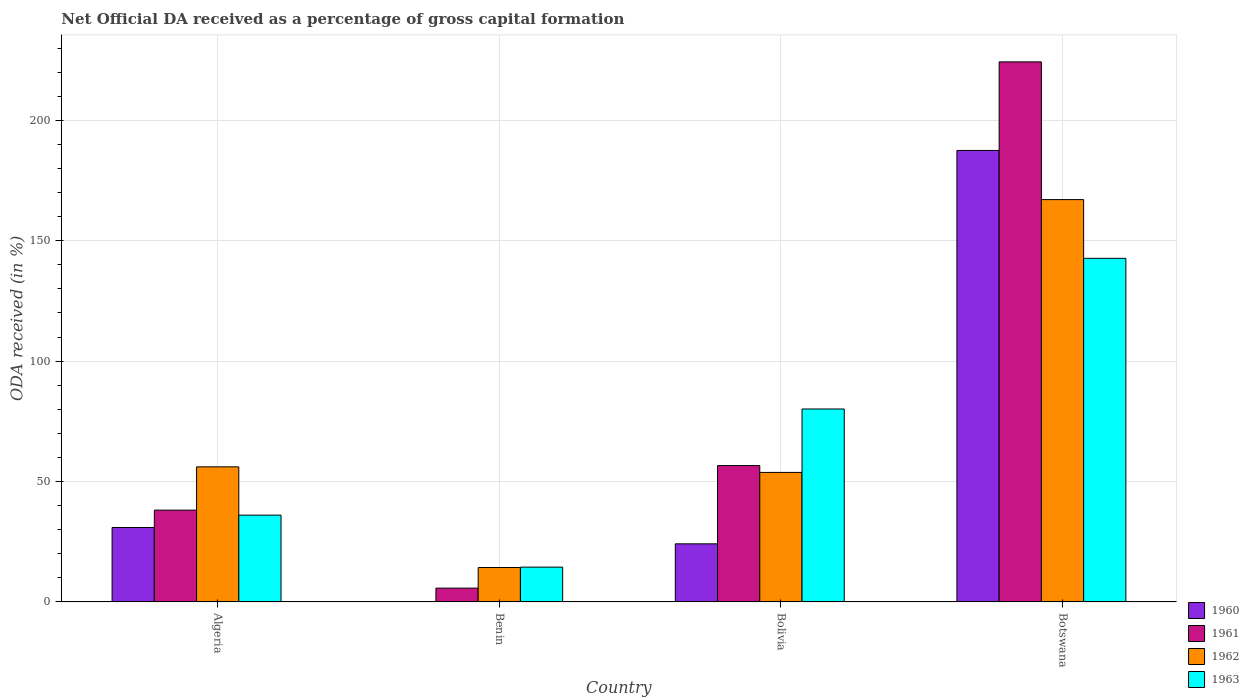How many bars are there on the 1st tick from the right?
Your response must be concise. 4. What is the label of the 3rd group of bars from the left?
Give a very brief answer. Bolivia. In how many cases, is the number of bars for a given country not equal to the number of legend labels?
Offer a terse response. 0. What is the net ODA received in 1960 in Bolivia?
Give a very brief answer. 24.12. Across all countries, what is the maximum net ODA received in 1963?
Make the answer very short. 142.68. Across all countries, what is the minimum net ODA received in 1962?
Your answer should be very brief. 14.28. In which country was the net ODA received in 1963 maximum?
Provide a short and direct response. Botswana. In which country was the net ODA received in 1960 minimum?
Your answer should be compact. Benin. What is the total net ODA received in 1960 in the graph?
Your answer should be compact. 242.58. What is the difference between the net ODA received in 1963 in Algeria and that in Benin?
Offer a terse response. 21.6. What is the difference between the net ODA received in 1962 in Botswana and the net ODA received in 1961 in Algeria?
Your answer should be compact. 128.96. What is the average net ODA received in 1963 per country?
Make the answer very short. 68.32. What is the difference between the net ODA received of/in 1961 and net ODA received of/in 1963 in Benin?
Offer a very short reply. -8.71. What is the ratio of the net ODA received in 1962 in Algeria to that in Botswana?
Offer a very short reply. 0.34. Is the net ODA received in 1960 in Algeria less than that in Botswana?
Offer a terse response. Yes. Is the difference between the net ODA received in 1961 in Algeria and Botswana greater than the difference between the net ODA received in 1963 in Algeria and Botswana?
Your answer should be very brief. No. What is the difference between the highest and the second highest net ODA received in 1961?
Make the answer very short. 167.65. What is the difference between the highest and the lowest net ODA received in 1962?
Your answer should be compact. 152.79. In how many countries, is the net ODA received in 1962 greater than the average net ODA received in 1962 taken over all countries?
Ensure brevity in your answer.  1. Is the sum of the net ODA received in 1962 in Bolivia and Botswana greater than the maximum net ODA received in 1960 across all countries?
Provide a succinct answer. Yes. What does the 1st bar from the right in Benin represents?
Your response must be concise. 1963. How many bars are there?
Offer a very short reply. 16. Are all the bars in the graph horizontal?
Make the answer very short. No. What is the difference between two consecutive major ticks on the Y-axis?
Offer a terse response. 50. Does the graph contain grids?
Offer a very short reply. Yes. How are the legend labels stacked?
Your answer should be compact. Vertical. What is the title of the graph?
Ensure brevity in your answer.  Net Official DA received as a percentage of gross capital formation. What is the label or title of the Y-axis?
Provide a short and direct response. ODA received (in %). What is the ODA received (in %) of 1960 in Algeria?
Keep it short and to the point. 30.9. What is the ODA received (in %) of 1961 in Algeria?
Your response must be concise. 38.11. What is the ODA received (in %) in 1962 in Algeria?
Offer a terse response. 56.09. What is the ODA received (in %) in 1963 in Algeria?
Your answer should be compact. 36.04. What is the ODA received (in %) of 1960 in Benin?
Provide a short and direct response. 0.08. What is the ODA received (in %) in 1961 in Benin?
Your answer should be very brief. 5.73. What is the ODA received (in %) in 1962 in Benin?
Give a very brief answer. 14.28. What is the ODA received (in %) of 1963 in Benin?
Your answer should be compact. 14.44. What is the ODA received (in %) of 1960 in Bolivia?
Give a very brief answer. 24.12. What is the ODA received (in %) of 1961 in Bolivia?
Provide a succinct answer. 56.62. What is the ODA received (in %) of 1962 in Bolivia?
Provide a succinct answer. 53.77. What is the ODA received (in %) in 1963 in Bolivia?
Offer a very short reply. 80.11. What is the ODA received (in %) of 1960 in Botswana?
Your response must be concise. 187.49. What is the ODA received (in %) in 1961 in Botswana?
Your response must be concise. 224.27. What is the ODA received (in %) in 1962 in Botswana?
Ensure brevity in your answer.  167.07. What is the ODA received (in %) in 1963 in Botswana?
Provide a short and direct response. 142.68. Across all countries, what is the maximum ODA received (in %) in 1960?
Make the answer very short. 187.49. Across all countries, what is the maximum ODA received (in %) of 1961?
Provide a succinct answer. 224.27. Across all countries, what is the maximum ODA received (in %) of 1962?
Your answer should be compact. 167.07. Across all countries, what is the maximum ODA received (in %) in 1963?
Make the answer very short. 142.68. Across all countries, what is the minimum ODA received (in %) of 1960?
Give a very brief answer. 0.08. Across all countries, what is the minimum ODA received (in %) of 1961?
Make the answer very short. 5.73. Across all countries, what is the minimum ODA received (in %) in 1962?
Your answer should be very brief. 14.28. Across all countries, what is the minimum ODA received (in %) in 1963?
Keep it short and to the point. 14.44. What is the total ODA received (in %) of 1960 in the graph?
Your answer should be compact. 242.58. What is the total ODA received (in %) in 1961 in the graph?
Provide a succinct answer. 324.72. What is the total ODA received (in %) in 1962 in the graph?
Give a very brief answer. 291.21. What is the total ODA received (in %) of 1963 in the graph?
Provide a short and direct response. 273.27. What is the difference between the ODA received (in %) of 1960 in Algeria and that in Benin?
Keep it short and to the point. 30.82. What is the difference between the ODA received (in %) in 1961 in Algeria and that in Benin?
Your response must be concise. 32.39. What is the difference between the ODA received (in %) of 1962 in Algeria and that in Benin?
Offer a terse response. 41.81. What is the difference between the ODA received (in %) in 1963 in Algeria and that in Benin?
Offer a terse response. 21.6. What is the difference between the ODA received (in %) in 1960 in Algeria and that in Bolivia?
Give a very brief answer. 6.78. What is the difference between the ODA received (in %) of 1961 in Algeria and that in Bolivia?
Give a very brief answer. -18.5. What is the difference between the ODA received (in %) in 1962 in Algeria and that in Bolivia?
Your answer should be compact. 2.31. What is the difference between the ODA received (in %) in 1963 in Algeria and that in Bolivia?
Offer a terse response. -44.08. What is the difference between the ODA received (in %) in 1960 in Algeria and that in Botswana?
Provide a short and direct response. -156.58. What is the difference between the ODA received (in %) of 1961 in Algeria and that in Botswana?
Your response must be concise. -186.15. What is the difference between the ODA received (in %) in 1962 in Algeria and that in Botswana?
Your answer should be compact. -110.98. What is the difference between the ODA received (in %) of 1963 in Algeria and that in Botswana?
Ensure brevity in your answer.  -106.64. What is the difference between the ODA received (in %) in 1960 in Benin and that in Bolivia?
Your answer should be compact. -24.04. What is the difference between the ODA received (in %) of 1961 in Benin and that in Bolivia?
Provide a succinct answer. -50.89. What is the difference between the ODA received (in %) of 1962 in Benin and that in Bolivia?
Provide a short and direct response. -39.5. What is the difference between the ODA received (in %) in 1963 in Benin and that in Bolivia?
Give a very brief answer. -65.67. What is the difference between the ODA received (in %) of 1960 in Benin and that in Botswana?
Your answer should be very brief. -187.41. What is the difference between the ODA received (in %) of 1961 in Benin and that in Botswana?
Give a very brief answer. -218.54. What is the difference between the ODA received (in %) in 1962 in Benin and that in Botswana?
Your response must be concise. -152.79. What is the difference between the ODA received (in %) in 1963 in Benin and that in Botswana?
Make the answer very short. -128.24. What is the difference between the ODA received (in %) in 1960 in Bolivia and that in Botswana?
Keep it short and to the point. -163.37. What is the difference between the ODA received (in %) in 1961 in Bolivia and that in Botswana?
Give a very brief answer. -167.65. What is the difference between the ODA received (in %) of 1962 in Bolivia and that in Botswana?
Make the answer very short. -113.3. What is the difference between the ODA received (in %) in 1963 in Bolivia and that in Botswana?
Your answer should be very brief. -62.56. What is the difference between the ODA received (in %) of 1960 in Algeria and the ODA received (in %) of 1961 in Benin?
Ensure brevity in your answer.  25.17. What is the difference between the ODA received (in %) of 1960 in Algeria and the ODA received (in %) of 1962 in Benin?
Provide a short and direct response. 16.62. What is the difference between the ODA received (in %) of 1960 in Algeria and the ODA received (in %) of 1963 in Benin?
Your answer should be very brief. 16.46. What is the difference between the ODA received (in %) of 1961 in Algeria and the ODA received (in %) of 1962 in Benin?
Your answer should be very brief. 23.84. What is the difference between the ODA received (in %) of 1961 in Algeria and the ODA received (in %) of 1963 in Benin?
Your response must be concise. 23.67. What is the difference between the ODA received (in %) of 1962 in Algeria and the ODA received (in %) of 1963 in Benin?
Keep it short and to the point. 41.65. What is the difference between the ODA received (in %) of 1960 in Algeria and the ODA received (in %) of 1961 in Bolivia?
Your response must be concise. -25.71. What is the difference between the ODA received (in %) in 1960 in Algeria and the ODA received (in %) in 1962 in Bolivia?
Offer a terse response. -22.87. What is the difference between the ODA received (in %) in 1960 in Algeria and the ODA received (in %) in 1963 in Bolivia?
Provide a succinct answer. -49.21. What is the difference between the ODA received (in %) in 1961 in Algeria and the ODA received (in %) in 1962 in Bolivia?
Ensure brevity in your answer.  -15.66. What is the difference between the ODA received (in %) in 1961 in Algeria and the ODA received (in %) in 1963 in Bolivia?
Provide a succinct answer. -42. What is the difference between the ODA received (in %) in 1962 in Algeria and the ODA received (in %) in 1963 in Bolivia?
Your answer should be very brief. -24.03. What is the difference between the ODA received (in %) in 1960 in Algeria and the ODA received (in %) in 1961 in Botswana?
Your answer should be compact. -193.36. What is the difference between the ODA received (in %) of 1960 in Algeria and the ODA received (in %) of 1962 in Botswana?
Your answer should be compact. -136.17. What is the difference between the ODA received (in %) of 1960 in Algeria and the ODA received (in %) of 1963 in Botswana?
Offer a very short reply. -111.78. What is the difference between the ODA received (in %) of 1961 in Algeria and the ODA received (in %) of 1962 in Botswana?
Your response must be concise. -128.96. What is the difference between the ODA received (in %) in 1961 in Algeria and the ODA received (in %) in 1963 in Botswana?
Provide a short and direct response. -104.56. What is the difference between the ODA received (in %) in 1962 in Algeria and the ODA received (in %) in 1963 in Botswana?
Give a very brief answer. -86.59. What is the difference between the ODA received (in %) in 1960 in Benin and the ODA received (in %) in 1961 in Bolivia?
Give a very brief answer. -56.54. What is the difference between the ODA received (in %) of 1960 in Benin and the ODA received (in %) of 1962 in Bolivia?
Your answer should be very brief. -53.7. What is the difference between the ODA received (in %) of 1960 in Benin and the ODA received (in %) of 1963 in Bolivia?
Ensure brevity in your answer.  -80.04. What is the difference between the ODA received (in %) of 1961 in Benin and the ODA received (in %) of 1962 in Bolivia?
Ensure brevity in your answer.  -48.05. What is the difference between the ODA received (in %) of 1961 in Benin and the ODA received (in %) of 1963 in Bolivia?
Ensure brevity in your answer.  -74.39. What is the difference between the ODA received (in %) in 1962 in Benin and the ODA received (in %) in 1963 in Bolivia?
Offer a very short reply. -65.84. What is the difference between the ODA received (in %) of 1960 in Benin and the ODA received (in %) of 1961 in Botswana?
Your response must be concise. -224.19. What is the difference between the ODA received (in %) of 1960 in Benin and the ODA received (in %) of 1962 in Botswana?
Provide a short and direct response. -166.99. What is the difference between the ODA received (in %) of 1960 in Benin and the ODA received (in %) of 1963 in Botswana?
Make the answer very short. -142.6. What is the difference between the ODA received (in %) in 1961 in Benin and the ODA received (in %) in 1962 in Botswana?
Your answer should be compact. -161.34. What is the difference between the ODA received (in %) in 1961 in Benin and the ODA received (in %) in 1963 in Botswana?
Give a very brief answer. -136.95. What is the difference between the ODA received (in %) of 1962 in Benin and the ODA received (in %) of 1963 in Botswana?
Make the answer very short. -128.4. What is the difference between the ODA received (in %) of 1960 in Bolivia and the ODA received (in %) of 1961 in Botswana?
Ensure brevity in your answer.  -200.15. What is the difference between the ODA received (in %) in 1960 in Bolivia and the ODA received (in %) in 1962 in Botswana?
Keep it short and to the point. -142.95. What is the difference between the ODA received (in %) in 1960 in Bolivia and the ODA received (in %) in 1963 in Botswana?
Offer a terse response. -118.56. What is the difference between the ODA received (in %) in 1961 in Bolivia and the ODA received (in %) in 1962 in Botswana?
Make the answer very short. -110.45. What is the difference between the ODA received (in %) in 1961 in Bolivia and the ODA received (in %) in 1963 in Botswana?
Your response must be concise. -86.06. What is the difference between the ODA received (in %) of 1962 in Bolivia and the ODA received (in %) of 1963 in Botswana?
Provide a succinct answer. -88.9. What is the average ODA received (in %) in 1960 per country?
Your answer should be compact. 60.65. What is the average ODA received (in %) of 1961 per country?
Ensure brevity in your answer.  81.18. What is the average ODA received (in %) of 1962 per country?
Provide a short and direct response. 72.8. What is the average ODA received (in %) in 1963 per country?
Provide a short and direct response. 68.32. What is the difference between the ODA received (in %) of 1960 and ODA received (in %) of 1961 in Algeria?
Your answer should be compact. -7.21. What is the difference between the ODA received (in %) in 1960 and ODA received (in %) in 1962 in Algeria?
Provide a succinct answer. -25.19. What is the difference between the ODA received (in %) of 1960 and ODA received (in %) of 1963 in Algeria?
Keep it short and to the point. -5.14. What is the difference between the ODA received (in %) of 1961 and ODA received (in %) of 1962 in Algeria?
Ensure brevity in your answer.  -17.98. What is the difference between the ODA received (in %) in 1961 and ODA received (in %) in 1963 in Algeria?
Your answer should be compact. 2.08. What is the difference between the ODA received (in %) in 1962 and ODA received (in %) in 1963 in Algeria?
Your response must be concise. 20.05. What is the difference between the ODA received (in %) of 1960 and ODA received (in %) of 1961 in Benin?
Keep it short and to the point. -5.65. What is the difference between the ODA received (in %) in 1960 and ODA received (in %) in 1962 in Benin?
Your answer should be very brief. -14.2. What is the difference between the ODA received (in %) in 1960 and ODA received (in %) in 1963 in Benin?
Offer a terse response. -14.36. What is the difference between the ODA received (in %) of 1961 and ODA received (in %) of 1962 in Benin?
Your answer should be very brief. -8.55. What is the difference between the ODA received (in %) of 1961 and ODA received (in %) of 1963 in Benin?
Offer a terse response. -8.71. What is the difference between the ODA received (in %) of 1962 and ODA received (in %) of 1963 in Benin?
Provide a short and direct response. -0.16. What is the difference between the ODA received (in %) of 1960 and ODA received (in %) of 1961 in Bolivia?
Offer a terse response. -32.5. What is the difference between the ODA received (in %) in 1960 and ODA received (in %) in 1962 in Bolivia?
Your response must be concise. -29.66. What is the difference between the ODA received (in %) in 1960 and ODA received (in %) in 1963 in Bolivia?
Provide a succinct answer. -56. What is the difference between the ODA received (in %) of 1961 and ODA received (in %) of 1962 in Bolivia?
Provide a succinct answer. 2.84. What is the difference between the ODA received (in %) of 1961 and ODA received (in %) of 1963 in Bolivia?
Offer a terse response. -23.5. What is the difference between the ODA received (in %) in 1962 and ODA received (in %) in 1963 in Bolivia?
Your answer should be very brief. -26.34. What is the difference between the ODA received (in %) in 1960 and ODA received (in %) in 1961 in Botswana?
Your response must be concise. -36.78. What is the difference between the ODA received (in %) of 1960 and ODA received (in %) of 1962 in Botswana?
Offer a very short reply. 20.42. What is the difference between the ODA received (in %) of 1960 and ODA received (in %) of 1963 in Botswana?
Give a very brief answer. 44.81. What is the difference between the ODA received (in %) of 1961 and ODA received (in %) of 1962 in Botswana?
Your answer should be compact. 57.2. What is the difference between the ODA received (in %) of 1961 and ODA received (in %) of 1963 in Botswana?
Your response must be concise. 81.59. What is the difference between the ODA received (in %) in 1962 and ODA received (in %) in 1963 in Botswana?
Your answer should be compact. 24.39. What is the ratio of the ODA received (in %) in 1960 in Algeria to that in Benin?
Your answer should be compact. 399.3. What is the ratio of the ODA received (in %) of 1961 in Algeria to that in Benin?
Offer a very short reply. 6.65. What is the ratio of the ODA received (in %) in 1962 in Algeria to that in Benin?
Your answer should be very brief. 3.93. What is the ratio of the ODA received (in %) of 1963 in Algeria to that in Benin?
Your answer should be compact. 2.5. What is the ratio of the ODA received (in %) in 1960 in Algeria to that in Bolivia?
Offer a very short reply. 1.28. What is the ratio of the ODA received (in %) in 1961 in Algeria to that in Bolivia?
Keep it short and to the point. 0.67. What is the ratio of the ODA received (in %) in 1962 in Algeria to that in Bolivia?
Your answer should be compact. 1.04. What is the ratio of the ODA received (in %) in 1963 in Algeria to that in Bolivia?
Make the answer very short. 0.45. What is the ratio of the ODA received (in %) of 1960 in Algeria to that in Botswana?
Your answer should be very brief. 0.16. What is the ratio of the ODA received (in %) of 1961 in Algeria to that in Botswana?
Your response must be concise. 0.17. What is the ratio of the ODA received (in %) in 1962 in Algeria to that in Botswana?
Make the answer very short. 0.34. What is the ratio of the ODA received (in %) in 1963 in Algeria to that in Botswana?
Your answer should be very brief. 0.25. What is the ratio of the ODA received (in %) in 1960 in Benin to that in Bolivia?
Offer a terse response. 0. What is the ratio of the ODA received (in %) of 1961 in Benin to that in Bolivia?
Your answer should be very brief. 0.1. What is the ratio of the ODA received (in %) of 1962 in Benin to that in Bolivia?
Provide a succinct answer. 0.27. What is the ratio of the ODA received (in %) in 1963 in Benin to that in Bolivia?
Your answer should be very brief. 0.18. What is the ratio of the ODA received (in %) in 1961 in Benin to that in Botswana?
Provide a succinct answer. 0.03. What is the ratio of the ODA received (in %) in 1962 in Benin to that in Botswana?
Offer a terse response. 0.09. What is the ratio of the ODA received (in %) in 1963 in Benin to that in Botswana?
Provide a short and direct response. 0.1. What is the ratio of the ODA received (in %) of 1960 in Bolivia to that in Botswana?
Provide a succinct answer. 0.13. What is the ratio of the ODA received (in %) of 1961 in Bolivia to that in Botswana?
Your response must be concise. 0.25. What is the ratio of the ODA received (in %) of 1962 in Bolivia to that in Botswana?
Make the answer very short. 0.32. What is the ratio of the ODA received (in %) of 1963 in Bolivia to that in Botswana?
Offer a terse response. 0.56. What is the difference between the highest and the second highest ODA received (in %) of 1960?
Offer a terse response. 156.58. What is the difference between the highest and the second highest ODA received (in %) in 1961?
Offer a very short reply. 167.65. What is the difference between the highest and the second highest ODA received (in %) of 1962?
Keep it short and to the point. 110.98. What is the difference between the highest and the second highest ODA received (in %) of 1963?
Make the answer very short. 62.56. What is the difference between the highest and the lowest ODA received (in %) in 1960?
Ensure brevity in your answer.  187.41. What is the difference between the highest and the lowest ODA received (in %) of 1961?
Keep it short and to the point. 218.54. What is the difference between the highest and the lowest ODA received (in %) in 1962?
Provide a short and direct response. 152.79. What is the difference between the highest and the lowest ODA received (in %) of 1963?
Your answer should be very brief. 128.24. 